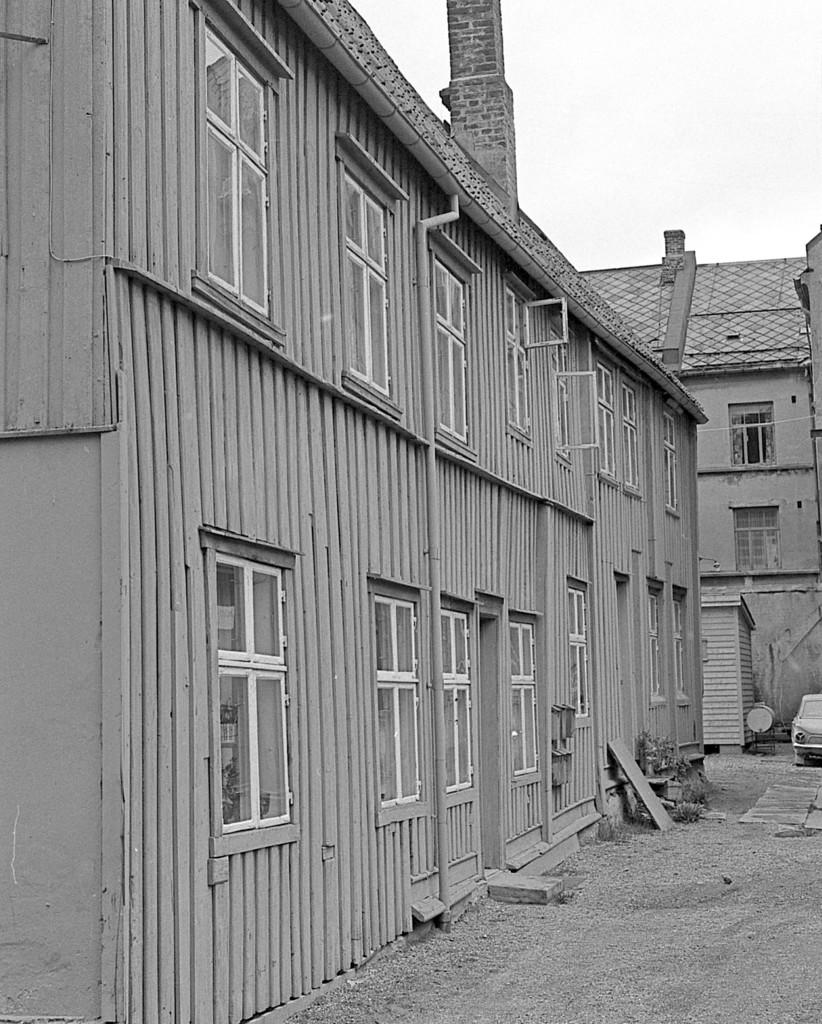What type of structure is in the foreground of the image? There is a building with windows in the image. Can you describe the background of the image? There is another building, a car, a shed, and the sky visible in the background of the image. What type of lace is used to decorate the windows of the building in the image? There is no mention of lace in the image, as it focuses on the structure and elements in the background. 